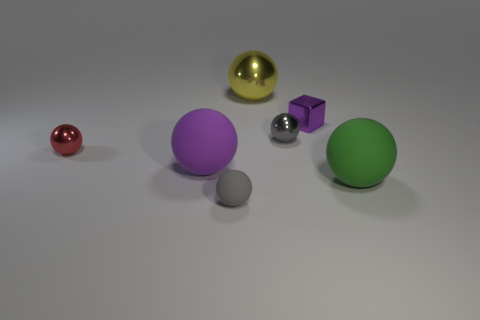Subtract all purple spheres. How many spheres are left? 5 Subtract all large metallic spheres. How many spheres are left? 5 Subtract all yellow spheres. Subtract all brown cylinders. How many spheres are left? 5 Add 3 large red matte objects. How many objects exist? 10 Subtract all cubes. How many objects are left? 6 Subtract all big cyan metal balls. Subtract all tiny matte things. How many objects are left? 6 Add 5 big shiny objects. How many big shiny objects are left? 6 Add 2 big green balls. How many big green balls exist? 3 Subtract 1 purple blocks. How many objects are left? 6 